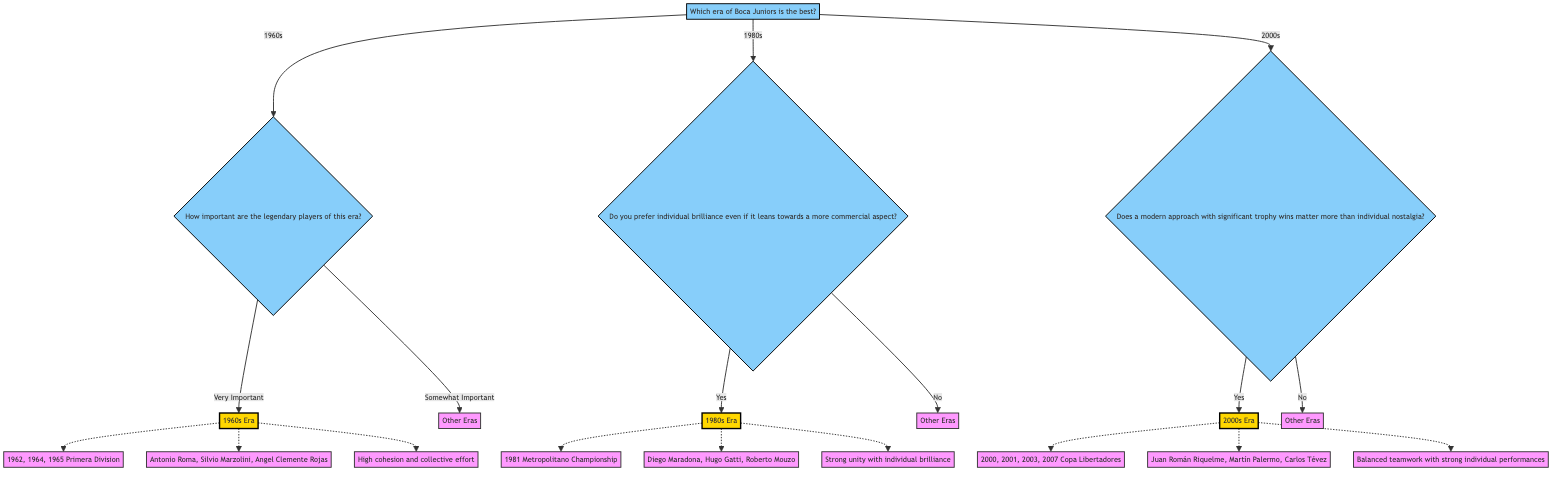What is the first question in the decision tree? The first question in the decision tree is presented at the top and asks about the best era of Boca Juniors based on key trophies, legendary players, and team spirit.
Answer: Which era of Boca Juniors is the best? How many eras are listed in the diagram? There are three distinct eras listed in the diagram: the 1960s, the 1980s, and the 2000s.
Answer: 3 What key trophies are associated with the 1960s era? The diagram shows the key trophies associated with the 1960s era, which includes the Primera Division titles from 1962, 1964, and 1965.
Answer: 1962 Primera Division, 1964 Primera Division, 1965 Primera Division What happens if the answer about legendary players in the 1960s is "Very Important"? If the answer is "Very Important," the flowchart indicates that the result points to the 1960s era, highlighting its significance.
Answer: 1960s Era What is the team's spirit description for the 1980s era? The team spirit described for the 1980s era is characterized as a strong unity with a mix of individual brilliance and collaboration.
Answer: Strong unity with a mix of individual brilliance and collaboration What will be the result if someone prefers individual brilliance in football? If an individual prefers individual brilliance, the path will lead to the 1980s era, prioritizing that approach in football during that period.
Answer: 1980s Era Which legendary players are mentioned for the 2000s era? The legendary players mentioned for the 2000s era are Juan Román Riquelme, Martín Palermo, and Carlos Tévez.
Answer: Juan Román Riquelme, Martín Palermo, Carlos Tévez What decision does the 2000s era create if modern trophy wins are considered more important? If modern trophy wins are valued more than nostalgia, the decision directs to the 2000s era as the preferred choice due to its success.
Answer: 2000s Era How does the decision tree classify responses if nostalgia is favored over modern wins? If nostalgia is favored over modern trophy wins, the chart indicates a general response to include "Other Eras," implying a preference for past accomplishments.
Answer: Other Eras 